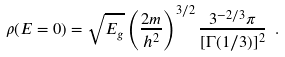<formula> <loc_0><loc_0><loc_500><loc_500>\rho ( E = 0 ) = \sqrt { E _ { g } } \left ( \frac { 2 m } { h ^ { 2 } } \right ) ^ { 3 / 2 } \frac { 3 ^ { - 2 / 3 } \pi } { [ \Gamma ( 1 / 3 ) ] ^ { 2 } } \ .</formula> 